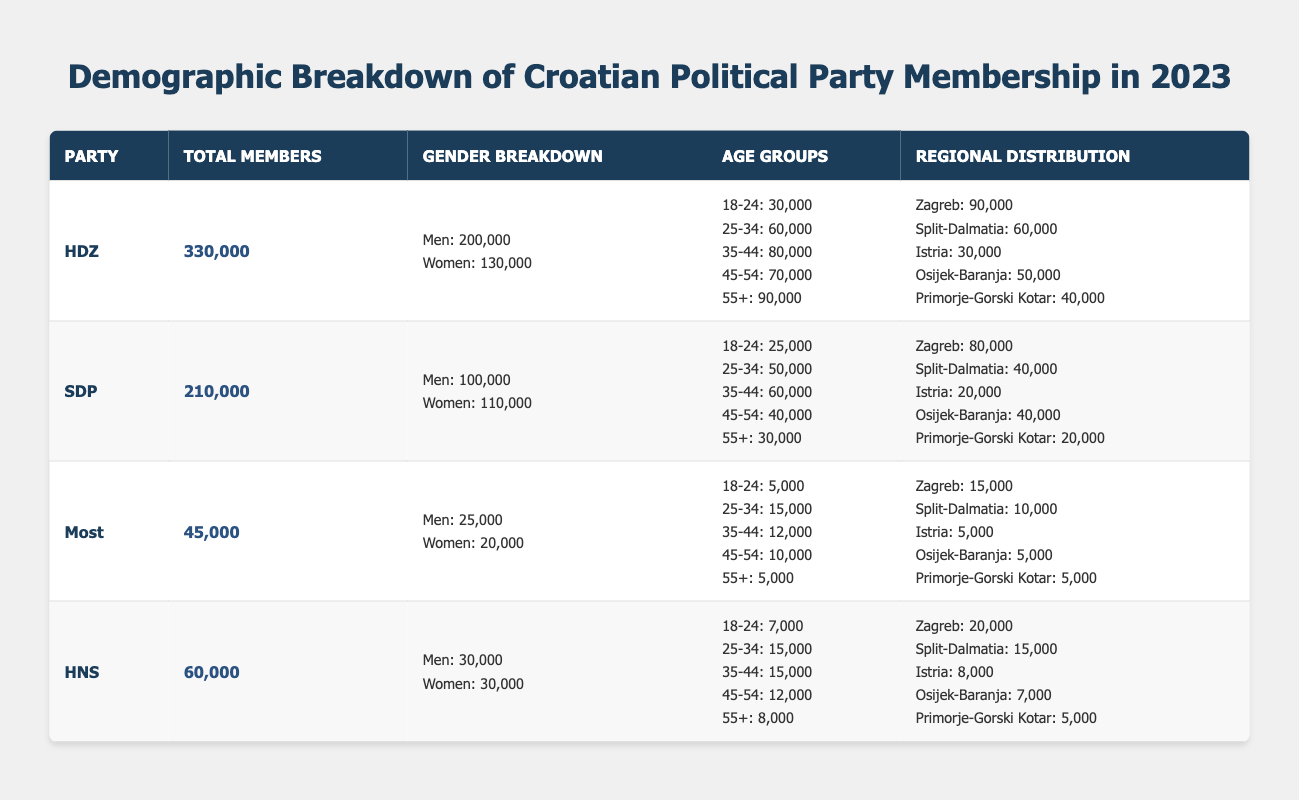What is the total membership of the HDZ party? Referring to the table, the total membership of the HDZ party is clearly stated as 330,000.
Answer: 330,000 How many women are members of the SDP party? Looking at the gender breakdown for the SDP party in the table, there are 110,000 women members.
Answer: 110,000 What is the average age group membership for the HDZ party? To find the average, we sum all the age group memberships: 30,000 + 60,000 + 80,000 + 70,000 + 90,000 = 330,000. Then, we divide by the number of age groups which is 5. Thus, 330,000/5 = 66,000 as the average membership per age group.
Answer: 66,000 Is the number of men members in the SDP greater than the number of women members? According to the table, the SDP has 100,000 male members and 110,000 female members, which indicates that the number of male members is not greater than the number of female members.
Answer: No Which political party has the highest total membership and how many members do they have? By reviewing the total membership numbers in the table, HDZ has the highest total with 330,000 members, compared to other parties.
Answer: HDZ, 330,000 What is the difference in membership between the most and least populated parties? The Most party has 45,000 members, while the HDZ has 330,000. The difference is 330,000 - 45,000 = 285,000.
Answer: 285,000 Which region has the most members for the HNS party and how many do they have? Referring to the regional distribution for the HNS party, Zagreb has the most members with 20,000.
Answer: Zagreb, 20,000 How many total members do the four parties, HDZ, SDP, Most, and HNS, have combined? Adding up the total memberships: 330,000 (HDZ) + 210,000 (SDP) + 45,000 (Most) + 60,000 (HNS) = 645,000 total members among these four parties.
Answer: 645,000 In which age group does the SDP party have the least members? By checking the age group breakdown for the SDP party, the age group 55+ has the least members at 30,000 compared to other age groups.
Answer: 55+, 30,000 